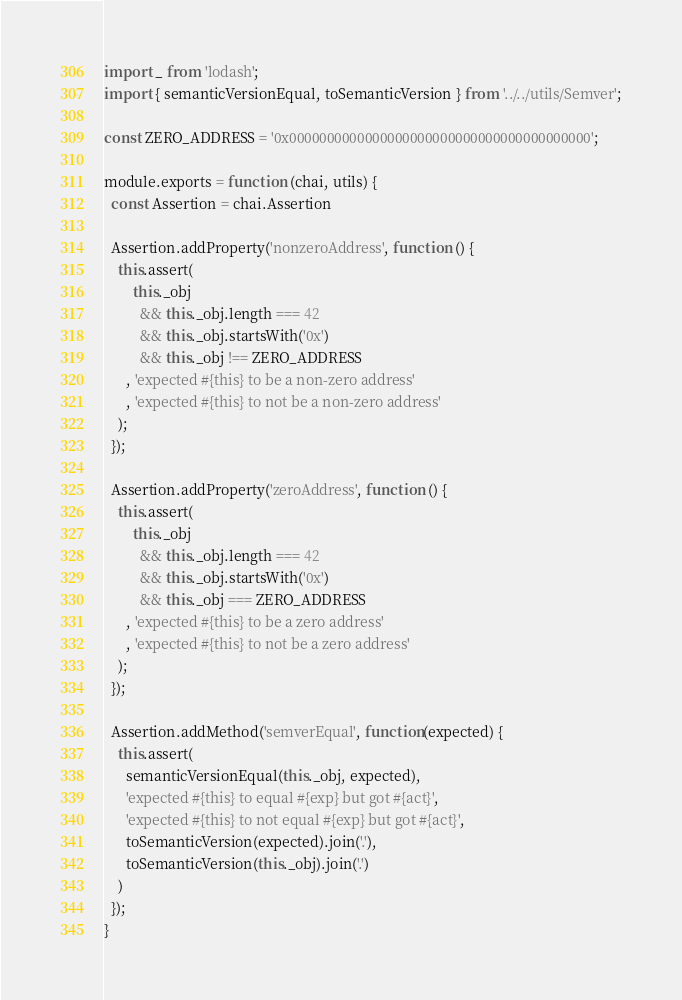Convert code to text. <code><loc_0><loc_0><loc_500><loc_500><_JavaScript_>import _ from 'lodash';
import { semanticVersionEqual, toSemanticVersion } from '../../utils/Semver';

const ZERO_ADDRESS = '0x0000000000000000000000000000000000000000';

module.exports = function (chai, utils) {
  const Assertion = chai.Assertion

  Assertion.addProperty('nonzeroAddress', function () {
    this.assert(
        this._obj 
          && this._obj.length === 42 
          && this._obj.startsWith('0x') 
          && this._obj !== ZERO_ADDRESS
      , 'expected #{this} to be a non-zero address'
      , 'expected #{this} to not be a non-zero address'
    );
  });

  Assertion.addProperty('zeroAddress', function () {
    this.assert(
        this._obj
          && this._obj.length === 42
          && this._obj.startsWith('0x')
          && this._obj === ZERO_ADDRESS
      , 'expected #{this} to be a zero address'
      , 'expected #{this} to not be a zero address'
    );
  });

  Assertion.addMethod('semverEqual', function(expected) {
    this.assert(
      semanticVersionEqual(this._obj, expected),
      'expected #{this} to equal #{exp} but got #{act}',
      'expected #{this} to not equal #{exp} but got #{act}',
      toSemanticVersion(expected).join('.'),
      toSemanticVersion(this._obj).join('.')
    )
  });
}
</code> 